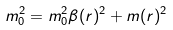Convert formula to latex. <formula><loc_0><loc_0><loc_500><loc_500>m _ { 0 } ^ { 2 } = m _ { 0 } ^ { 2 } \beta ( r ) ^ { 2 } + m ( r ) ^ { 2 }</formula> 